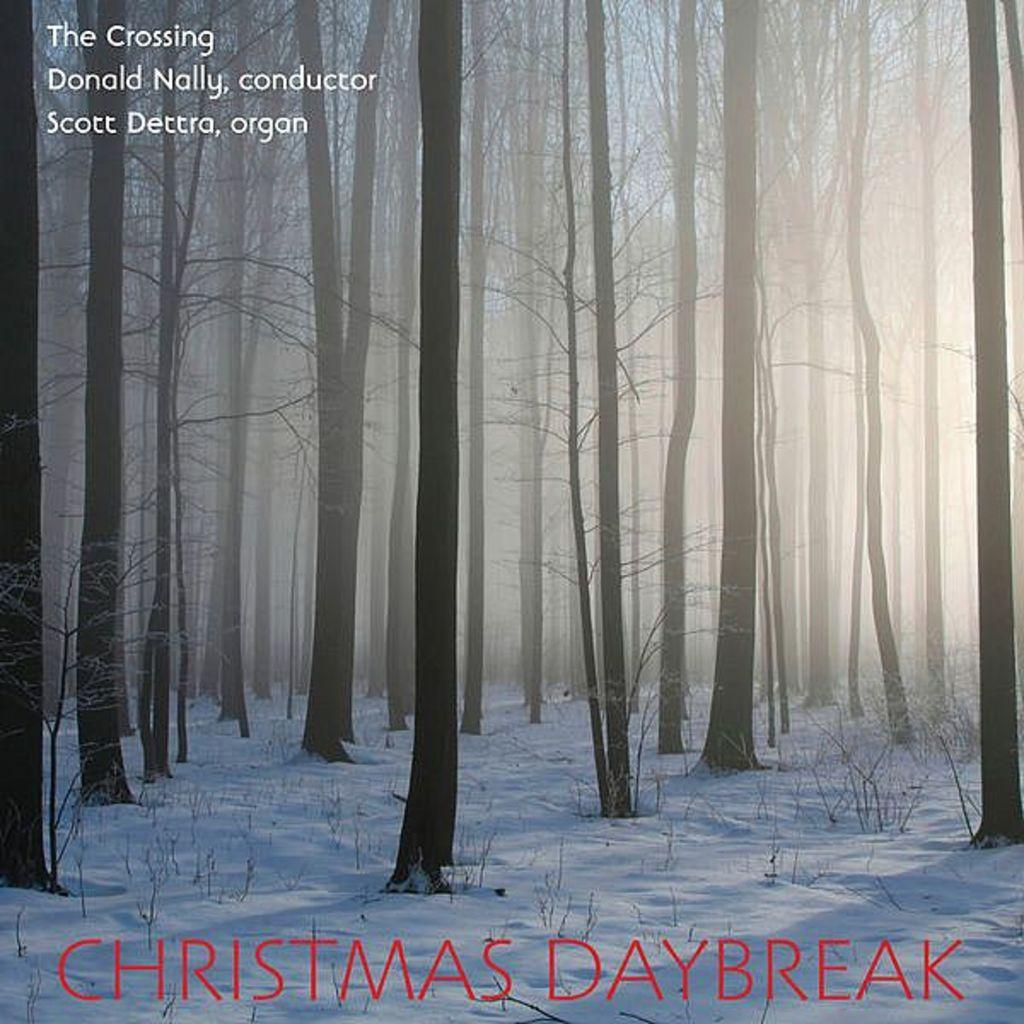What type of vegetation is present in the image? There are many trees in the image. What is the condition of the ground in the image? There is snow on the ground in the image. Are there any words or phrases visible in the image? Yes, there are texts at the top and bottom of the image. How many feet can be seen walking through the snow in the image? There are no feet or people visible in the image; it only shows trees and snow on the ground. What type of story is being told in the image? There is no story being told in the image; it is a photograph or illustration of trees and snow. 